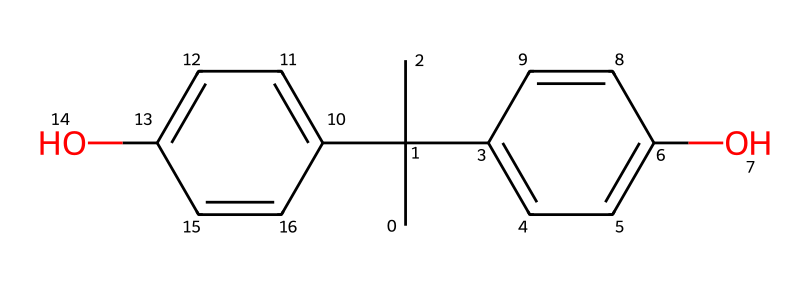What is the molecular formula of this chemical? The SMILES representation can be analyzed to identify the number of carbon (C), hydrogen (H), and oxygen (O) atoms present. In this case, the structure contains 15 carbon atoms, 16 hydrogen atoms, and 2 oxygen atoms, leading to the molecular formula C15H16O2.
Answer: C15H16O2 How many hydroxyl (OH) groups are present in this chemical? By examining the structure in the SMILES notation, the presence of -OH groups can be identified. In this case, there are two instances of -OH, indicating there are two hydroxyl groups in the molecule.
Answer: 2 What type of chemical reaction can produce BPA? Bisphenol A is typically produced through the condensation reaction of acetone and phenol in the presence of an acid catalyst. This involves the substitution of the hydroxyl groups with the phenol groups.
Answer: condensation Does this chemical have any aromatic rings? The structure includes multiple benzene rings, which can be confirmed by identifying the cyclic carbon arrangements with alternating double bonds in the chemical drawing. Therefore, BPA contains aromatic rings.
Answer: yes What is the role of BPA in plastic production? Bisphenol A is primarily used as a key monomer in the production of polycarbonate plastics and epoxy resins, which are common in many office supplies due to their durability and resistance.
Answer: monomer Is bisphenol A considered an endocrine disruptor? Scientific research has indicated that BPA can mimic estrogen and interfere with hormonal functions in the body, thus qualifying it as an endocrine disruptor.
Answer: yes 